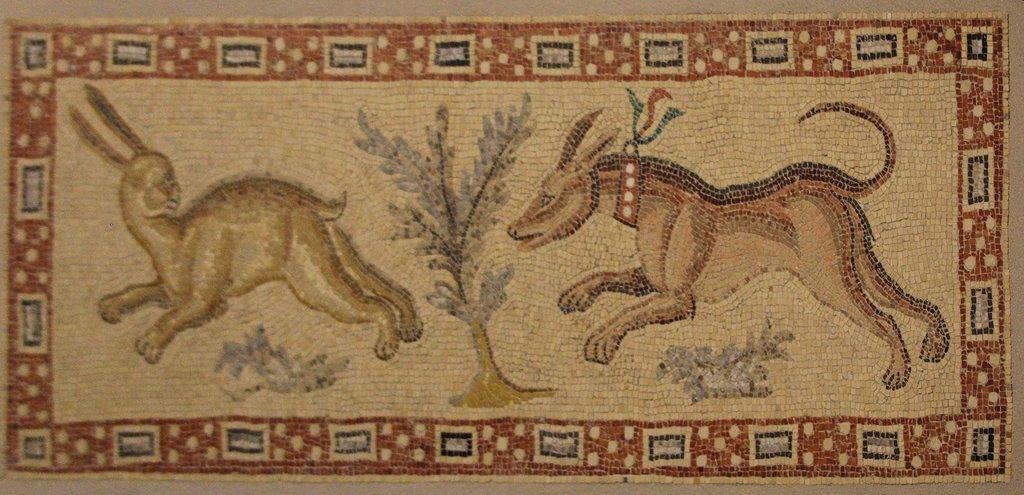What is present on the floor in the image? There is a mat in the image. What types of living organisms are on the mat? There are two animals on the mat. What other object is on the mat besides the animals? There is one plant on the mat. What type of wire can be seen connecting the two animals on the mat? There is no wire connecting the two animals on the mat in the image. What time of day is depicted in the image? The time of day is not discernible from the image. 